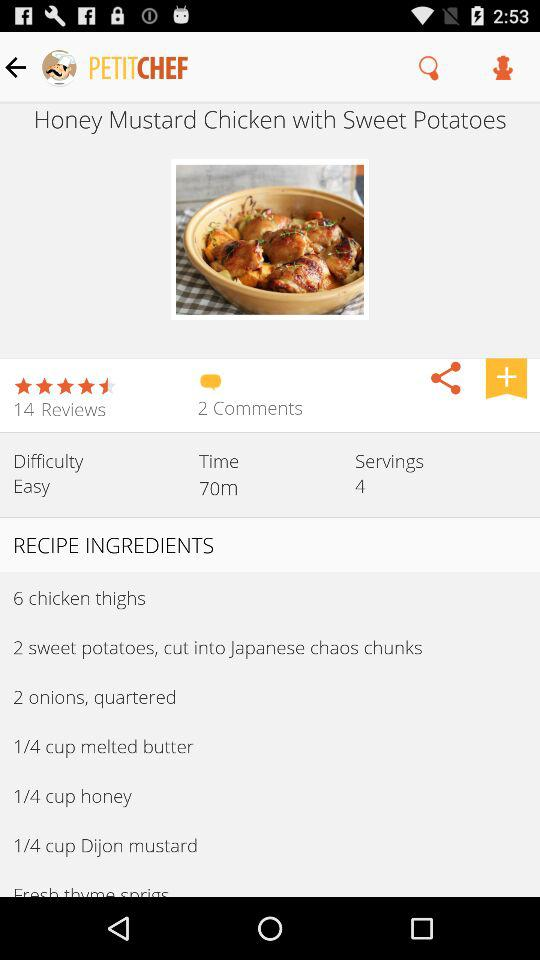How many reviews are there? There are 14 reviews. 